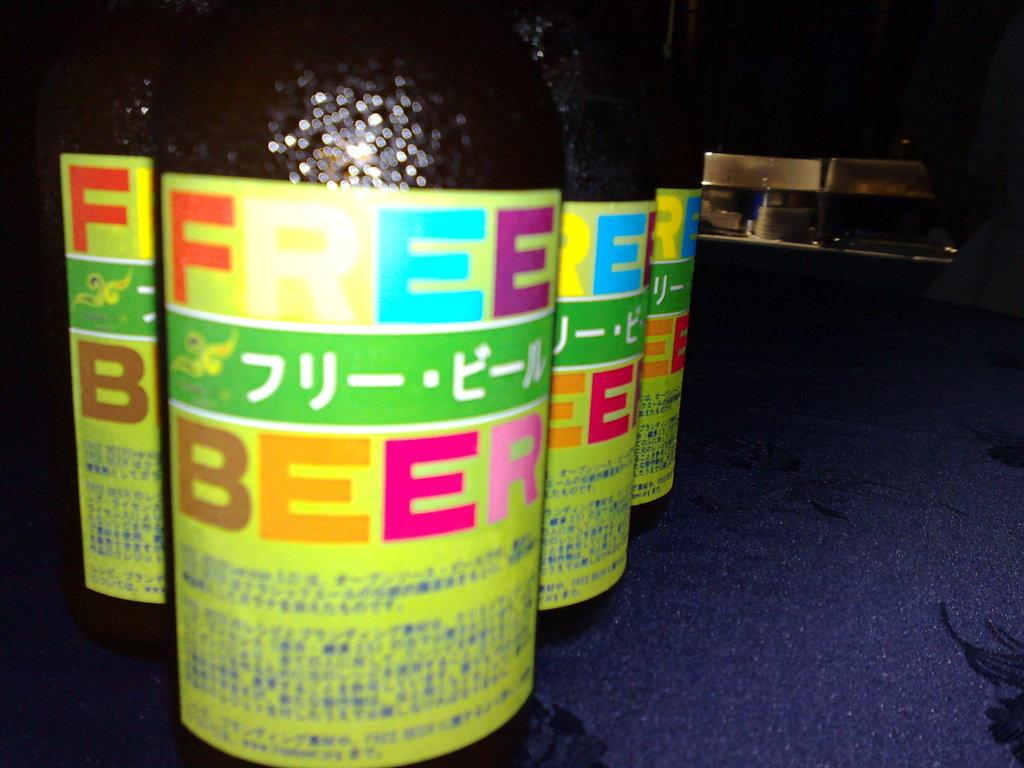<image>
Render a clear and concise summary of the photo. a few beer bottles that are all together 